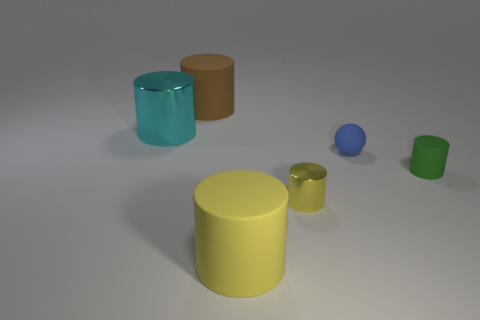Subtract all large brown matte cylinders. How many cylinders are left? 4 Subtract 1 cylinders. How many cylinders are left? 4 Subtract all brown cylinders. How many cylinders are left? 4 Subtract all red cylinders. Subtract all brown spheres. How many cylinders are left? 5 Add 2 small spheres. How many objects exist? 8 Subtract all cylinders. How many objects are left? 1 Subtract 1 green cylinders. How many objects are left? 5 Subtract all brown spheres. Subtract all big brown rubber cylinders. How many objects are left? 5 Add 3 small blue things. How many small blue things are left? 4 Add 6 large cyan cylinders. How many large cyan cylinders exist? 7 